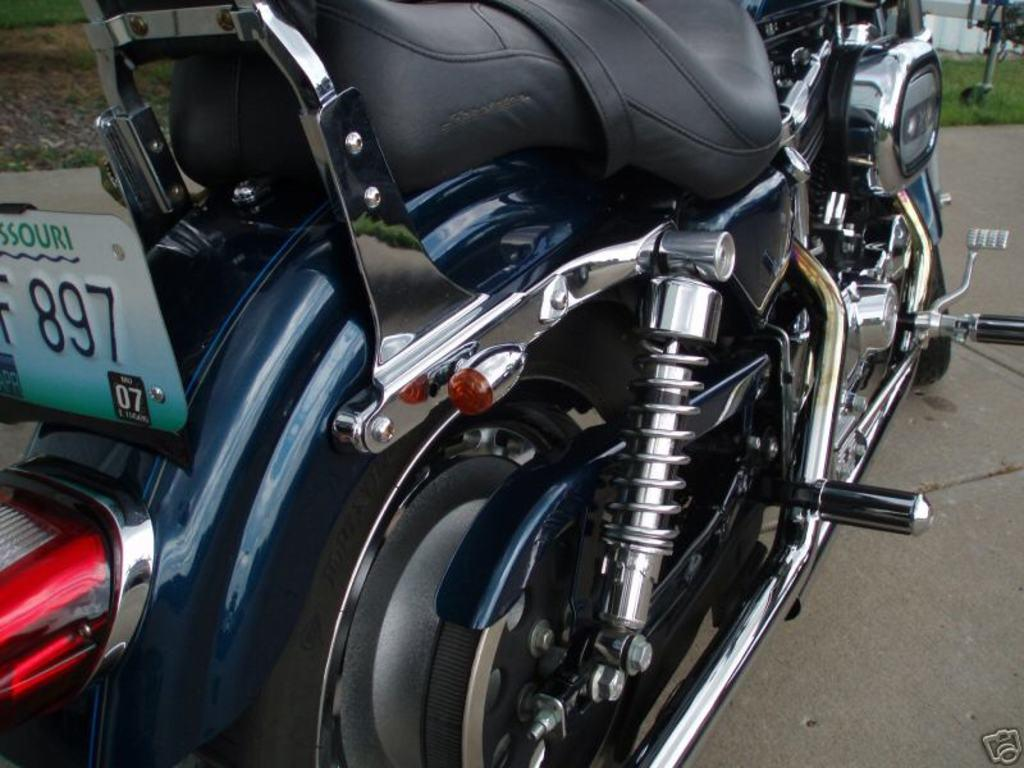What is the main subject of the image? The main subject of the image is a motorbike. Where is the motorbike located in the image? The motorbike is on the road in the image. What can be seen in the background of the image? There is grassland visible in the background of the image. How much income does the motorbike generate in the image? The image does not provide information about the motorbike's income, as it is not a living entity capable of generating income. 